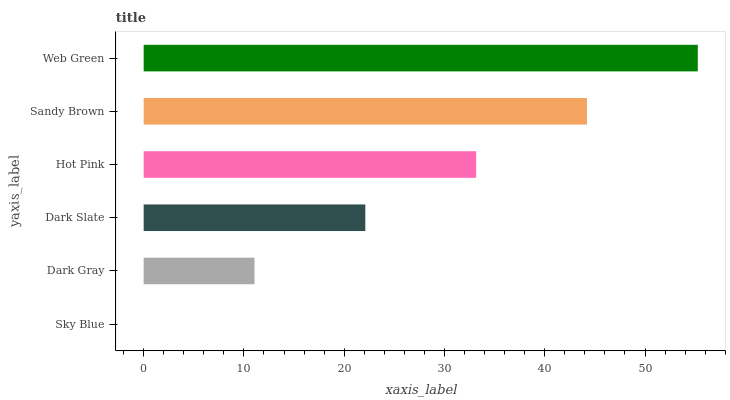Is Sky Blue the minimum?
Answer yes or no. Yes. Is Web Green the maximum?
Answer yes or no. Yes. Is Dark Gray the minimum?
Answer yes or no. No. Is Dark Gray the maximum?
Answer yes or no. No. Is Dark Gray greater than Sky Blue?
Answer yes or no. Yes. Is Sky Blue less than Dark Gray?
Answer yes or no. Yes. Is Sky Blue greater than Dark Gray?
Answer yes or no. No. Is Dark Gray less than Sky Blue?
Answer yes or no. No. Is Hot Pink the high median?
Answer yes or no. Yes. Is Dark Slate the low median?
Answer yes or no. Yes. Is Sky Blue the high median?
Answer yes or no. No. Is Hot Pink the low median?
Answer yes or no. No. 